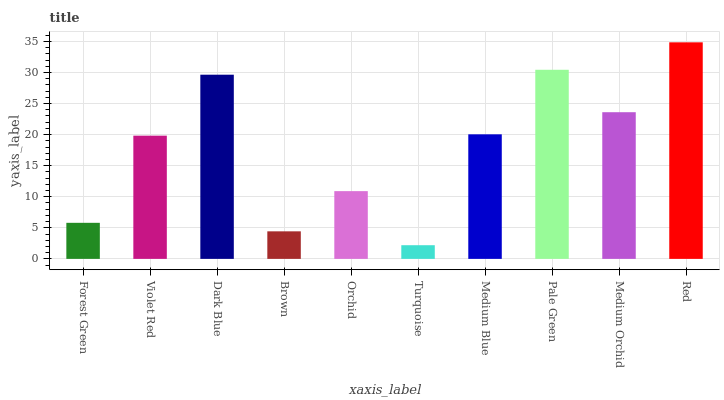Is Turquoise the minimum?
Answer yes or no. Yes. Is Red the maximum?
Answer yes or no. Yes. Is Violet Red the minimum?
Answer yes or no. No. Is Violet Red the maximum?
Answer yes or no. No. Is Violet Red greater than Forest Green?
Answer yes or no. Yes. Is Forest Green less than Violet Red?
Answer yes or no. Yes. Is Forest Green greater than Violet Red?
Answer yes or no. No. Is Violet Red less than Forest Green?
Answer yes or no. No. Is Medium Blue the high median?
Answer yes or no. Yes. Is Violet Red the low median?
Answer yes or no. Yes. Is Red the high median?
Answer yes or no. No. Is Pale Green the low median?
Answer yes or no. No. 